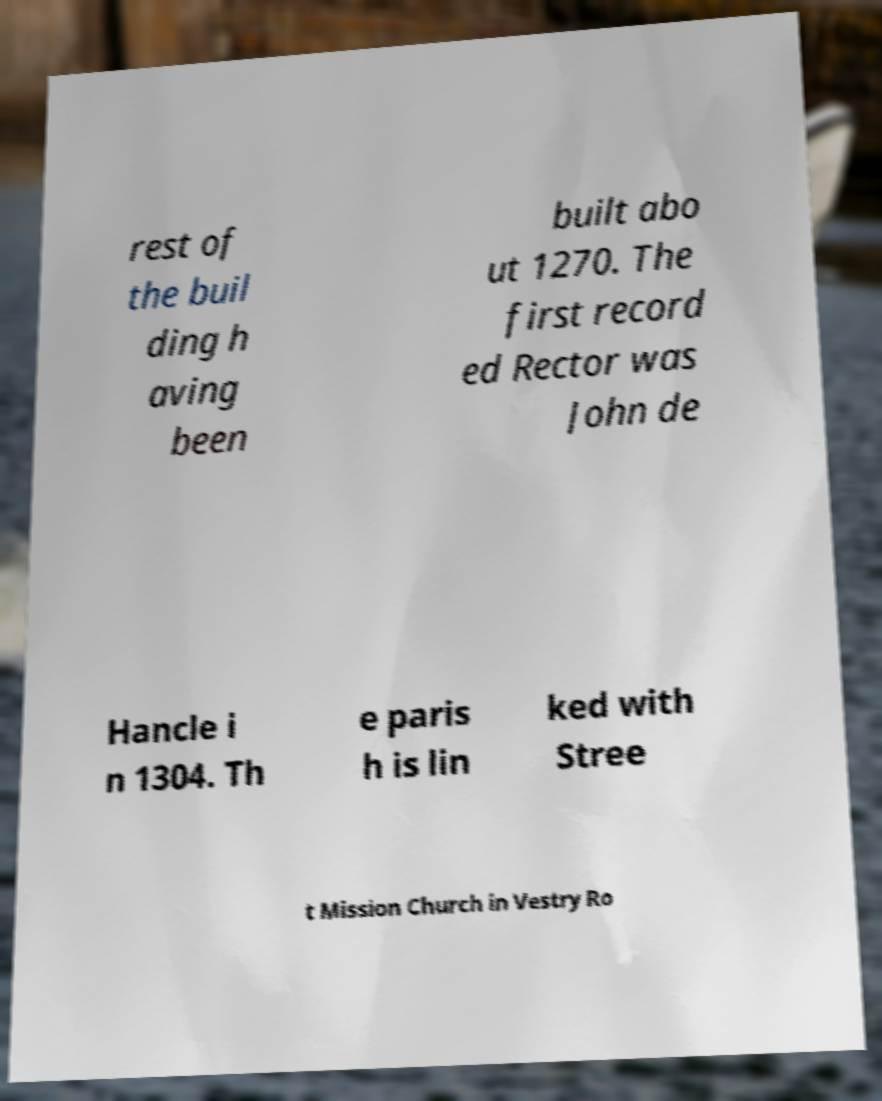Could you assist in decoding the text presented in this image and type it out clearly? rest of the buil ding h aving been built abo ut 1270. The first record ed Rector was John de Hancle i n 1304. Th e paris h is lin ked with Stree t Mission Church in Vestry Ro 